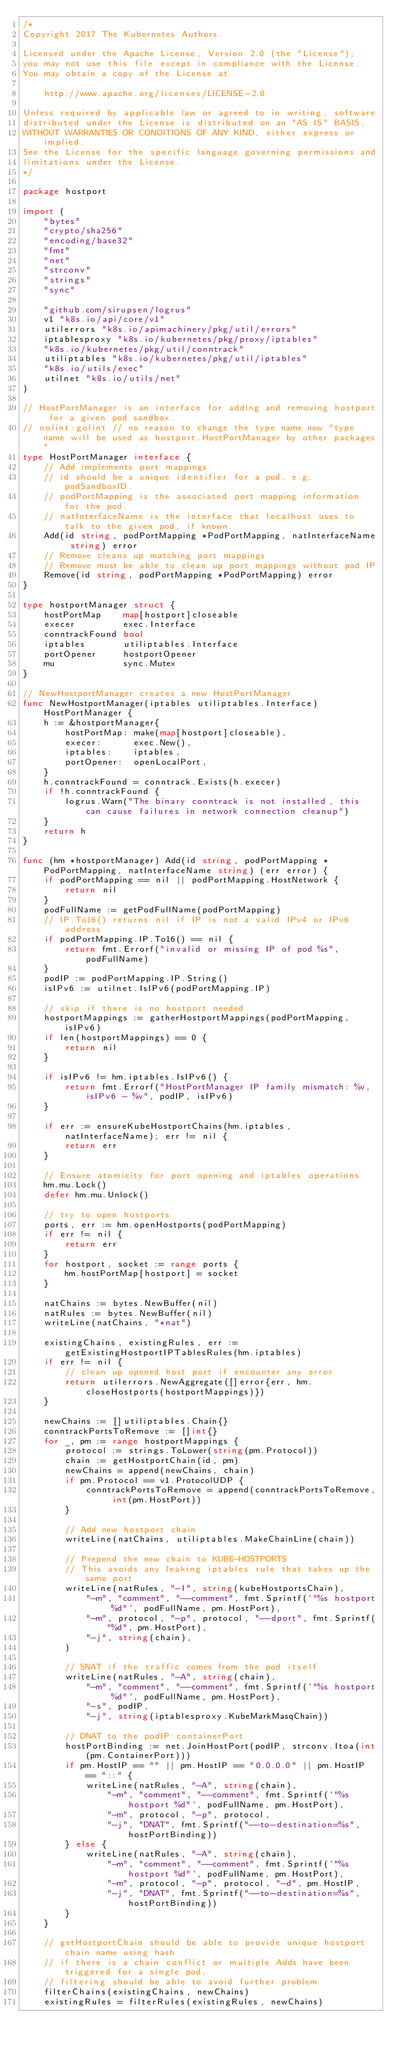Convert code to text. <code><loc_0><loc_0><loc_500><loc_500><_Go_>/*
Copyright 2017 The Kubernetes Authors.

Licensed under the Apache License, Version 2.0 (the "License");
you may not use this file except in compliance with the License.
You may obtain a copy of the License at

    http://www.apache.org/licenses/LICENSE-2.0

Unless required by applicable law or agreed to in writing, software
distributed under the License is distributed on an "AS IS" BASIS,
WITHOUT WARRANTIES OR CONDITIONS OF ANY KIND, either express or implied.
See the License for the specific language governing permissions and
limitations under the License.
*/

package hostport

import (
	"bytes"
	"crypto/sha256"
	"encoding/base32"
	"fmt"
	"net"
	"strconv"
	"strings"
	"sync"

	"github.com/sirupsen/logrus"
	v1 "k8s.io/api/core/v1"
	utilerrors "k8s.io/apimachinery/pkg/util/errors"
	iptablesproxy "k8s.io/kubernetes/pkg/proxy/iptables"
	"k8s.io/kubernetes/pkg/util/conntrack"
	utiliptables "k8s.io/kubernetes/pkg/util/iptables"
	"k8s.io/utils/exec"
	utilnet "k8s.io/utils/net"
)

// HostPortManager is an interface for adding and removing hostport for a given pod sandbox.
// nolint:golint // no reason to change the type name now "type name will be used as hostport.HostPortManager by other packages"
type HostPortManager interface {
	// Add implements port mappings.
	// id should be a unique identifier for a pod, e.g. podSandboxID.
	// podPortMapping is the associated port mapping information for the pod.
	// natInterfaceName is the interface that localhost uses to talk to the given pod, if known.
	Add(id string, podPortMapping *PodPortMapping, natInterfaceName string) error
	// Remove cleans up matching port mappings
	// Remove must be able to clean up port mappings without pod IP
	Remove(id string, podPortMapping *PodPortMapping) error
}

type hostportManager struct {
	hostPortMap    map[hostport]closeable
	execer         exec.Interface
	conntrackFound bool
	iptables       utiliptables.Interface
	portOpener     hostportOpener
	mu             sync.Mutex
}

// NewHostportManager creates a new HostPortManager
func NewHostportManager(iptables utiliptables.Interface) HostPortManager {
	h := &hostportManager{
		hostPortMap: make(map[hostport]closeable),
		execer:      exec.New(),
		iptables:    iptables,
		portOpener:  openLocalPort,
	}
	h.conntrackFound = conntrack.Exists(h.execer)
	if !h.conntrackFound {
		logrus.Warn("The binary conntrack is not installed, this can cause failures in network connection cleanup")
	}
	return h
}

func (hm *hostportManager) Add(id string, podPortMapping *PodPortMapping, natInterfaceName string) (err error) {
	if podPortMapping == nil || podPortMapping.HostNetwork {
		return nil
	}
	podFullName := getPodFullName(podPortMapping)
	// IP.To16() returns nil if IP is not a valid IPv4 or IPv6 address
	if podPortMapping.IP.To16() == nil {
		return fmt.Errorf("invalid or missing IP of pod %s", podFullName)
	}
	podIP := podPortMapping.IP.String()
	isIPv6 := utilnet.IsIPv6(podPortMapping.IP)

	// skip if there is no hostport needed
	hostportMappings := gatherHostportMappings(podPortMapping, isIPv6)
	if len(hostportMappings) == 0 {
		return nil
	}

	if isIPv6 != hm.iptables.IsIPv6() {
		return fmt.Errorf("HostPortManager IP family mismatch: %v, isIPv6 - %v", podIP, isIPv6)
	}

	if err := ensureKubeHostportChains(hm.iptables, natInterfaceName); err != nil {
		return err
	}

	// Ensure atomicity for port opening and iptables operations
	hm.mu.Lock()
	defer hm.mu.Unlock()

	// try to open hostports
	ports, err := hm.openHostports(podPortMapping)
	if err != nil {
		return err
	}
	for hostport, socket := range ports {
		hm.hostPortMap[hostport] = socket
	}

	natChains := bytes.NewBuffer(nil)
	natRules := bytes.NewBuffer(nil)
	writeLine(natChains, "*nat")

	existingChains, existingRules, err := getExistingHostportIPTablesRules(hm.iptables)
	if err != nil {
		// clean up opened host port if encounter any error
		return utilerrors.NewAggregate([]error{err, hm.closeHostports(hostportMappings)})
	}

	newChains := []utiliptables.Chain{}
	conntrackPortsToRemove := []int{}
	for _, pm := range hostportMappings {
		protocol := strings.ToLower(string(pm.Protocol))
		chain := getHostportChain(id, pm)
		newChains = append(newChains, chain)
		if pm.Protocol == v1.ProtocolUDP {
			conntrackPortsToRemove = append(conntrackPortsToRemove, int(pm.HostPort))
		}

		// Add new hostport chain
		writeLine(natChains, utiliptables.MakeChainLine(chain))

		// Prepend the new chain to KUBE-HOSTPORTS
		// This avoids any leaking iptables rule that takes up the same port
		writeLine(natRules, "-I", string(kubeHostportsChain),
			"-m", "comment", "--comment", fmt.Sprintf(`"%s hostport %d"`, podFullName, pm.HostPort),
			"-m", protocol, "-p", protocol, "--dport", fmt.Sprintf("%d", pm.HostPort),
			"-j", string(chain),
		)

		// SNAT if the traffic comes from the pod itself
		writeLine(natRules, "-A", string(chain),
			"-m", "comment", "--comment", fmt.Sprintf(`"%s hostport %d"`, podFullName, pm.HostPort),
			"-s", podIP,
			"-j", string(iptablesproxy.KubeMarkMasqChain))

		// DNAT to the podIP:containerPort
		hostPortBinding := net.JoinHostPort(podIP, strconv.Itoa(int(pm.ContainerPort)))
		if pm.HostIP == "" || pm.HostIP == "0.0.0.0" || pm.HostIP == "::" {
			writeLine(natRules, "-A", string(chain),
				"-m", "comment", "--comment", fmt.Sprintf(`"%s hostport %d"`, podFullName, pm.HostPort),
				"-m", protocol, "-p", protocol,
				"-j", "DNAT", fmt.Sprintf("--to-destination=%s", hostPortBinding))
		} else {
			writeLine(natRules, "-A", string(chain),
				"-m", "comment", "--comment", fmt.Sprintf(`"%s hostport %d"`, podFullName, pm.HostPort),
				"-m", protocol, "-p", protocol, "-d", pm.HostIP,
				"-j", "DNAT", fmt.Sprintf("--to-destination=%s", hostPortBinding))
		}
	}

	// getHostportChain should be able to provide unique hostport chain name using hash
	// if there is a chain conflict or multiple Adds have been triggered for a single pod,
	// filtering should be able to avoid further problem
	filterChains(existingChains, newChains)
	existingRules = filterRules(existingRules, newChains)
</code> 